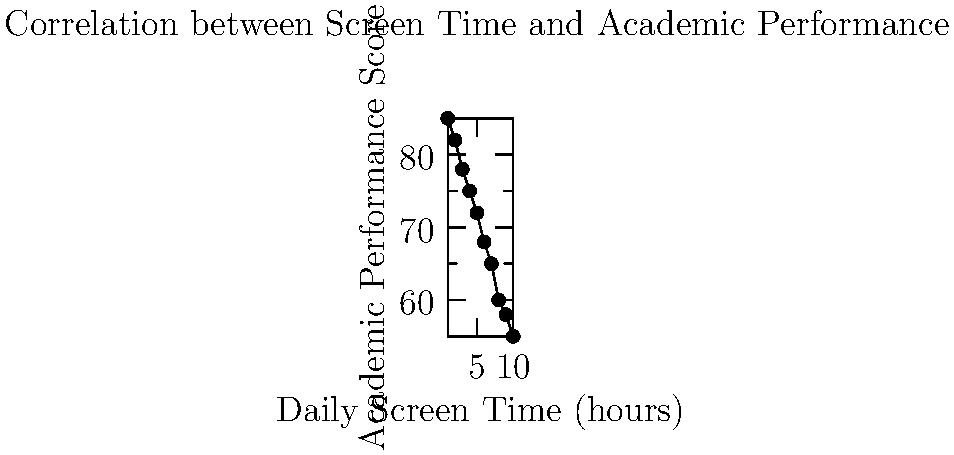As an education technology blogger, you're analyzing the relationship between daily screen time and academic performance. Based on the scatter plot, what type of correlation exists between these variables, and what implications might this have for digital learning strategies? To answer this question, we need to analyze the scatter plot step by step:

1. Observe the overall trend: As we move from left to right (increasing screen time), the points generally move downward (decreasing academic performance).

2. Identify the correlation type: This downward trend indicates a negative or inverse correlation between screen time and academic performance.

3. Assess the strength of the correlation: The points form a fairly consistent downward pattern without much scatter, suggesting a strong negative correlation.

4. Calculate the correlation coefficient (optional): For a more precise measure, we could calculate Pearson's correlation coefficient, but visually we can estimate it's close to -1.

5. Interpret the results: As daily screen time increases, academic performance tends to decrease.

6. Consider implications for digital learning:
   a) Excessive screen time might negatively impact academic performance.
   b) Digital learning strategies should be designed to maximize efficiency and minimize unnecessary screen time.
   c) Educators and ed-tech developers should focus on creating engaging, high-quality content that achieves learning objectives in less time.
   d) Balancing digital and non-digital learning activities may be crucial for optimal academic performance.
   e) Time management and self-regulation skills should be emphasized when implementing digital learning strategies.

These insights are valuable for developing effective ed-tech solutions and guiding best practices in digital education.
Answer: Strong negative correlation; suggests need for balanced, efficient digital learning strategies to mitigate potential negative effects of extended screen time on academic performance. 